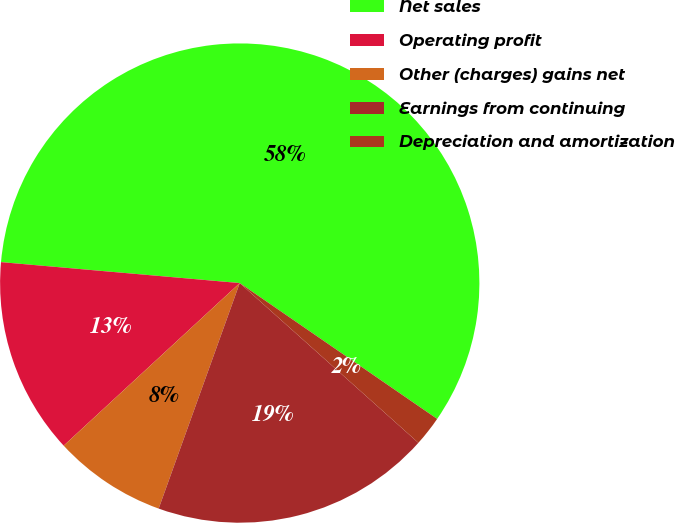Convert chart to OTSL. <chart><loc_0><loc_0><loc_500><loc_500><pie_chart><fcel>Net sales<fcel>Operating profit<fcel>Other (charges) gains net<fcel>Earnings from continuing<fcel>Depreciation and amortization<nl><fcel>58.2%<fcel>13.26%<fcel>7.64%<fcel>18.88%<fcel>2.02%<nl></chart> 